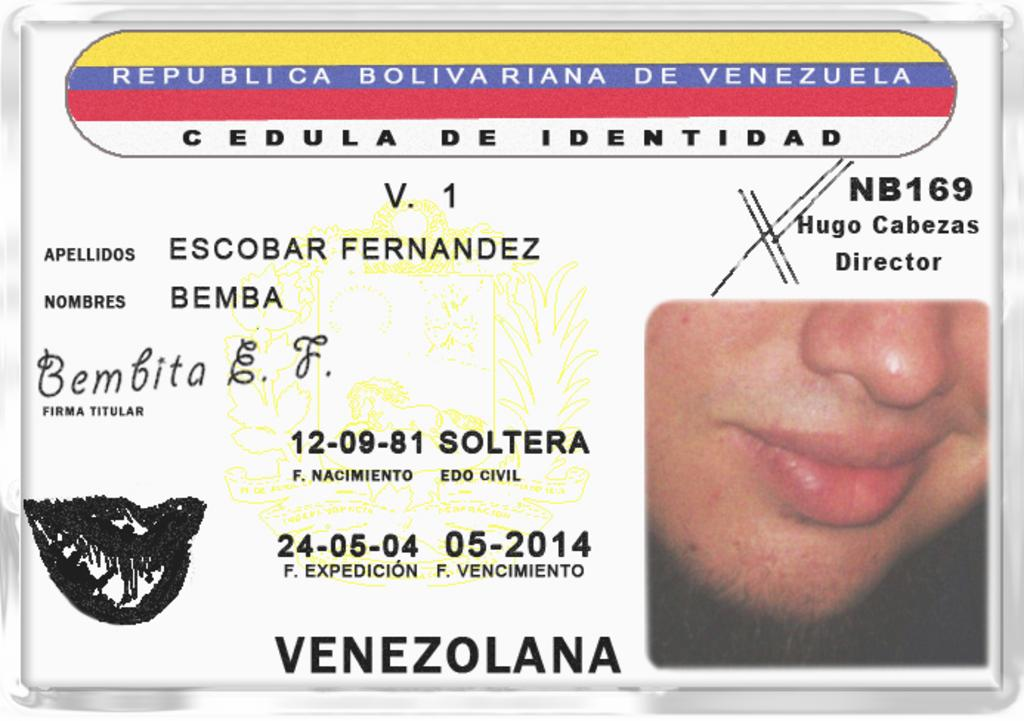What can be seen in the image related to a person? There is a person's half face visible in the image. What else is present in the image besides the person's face? There is writing in the image. What is the color of the background in the image? The background of the image is white. What type of rhythm can be heard in the image? There is no sound or rhythm present in the image, as it is a static visual representation. 